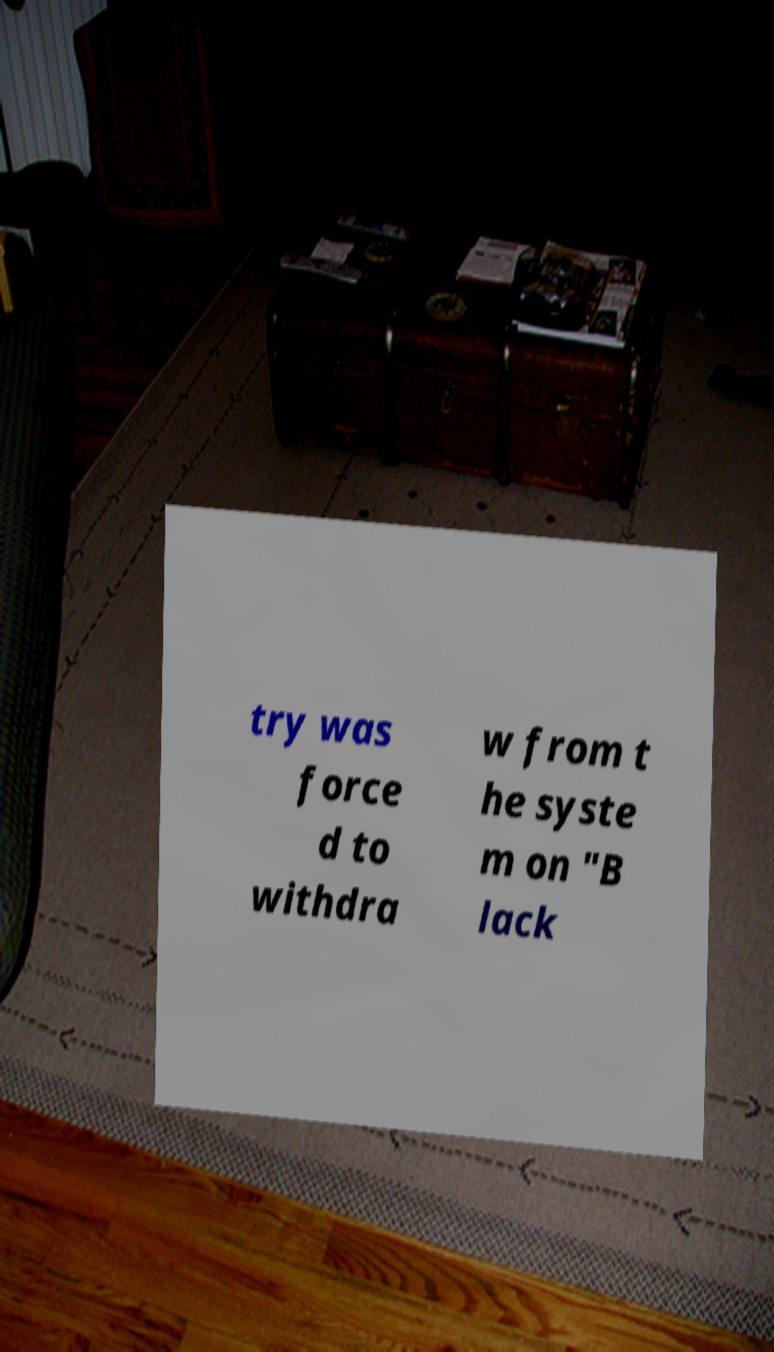Could you assist in decoding the text presented in this image and type it out clearly? try was force d to withdra w from t he syste m on "B lack 